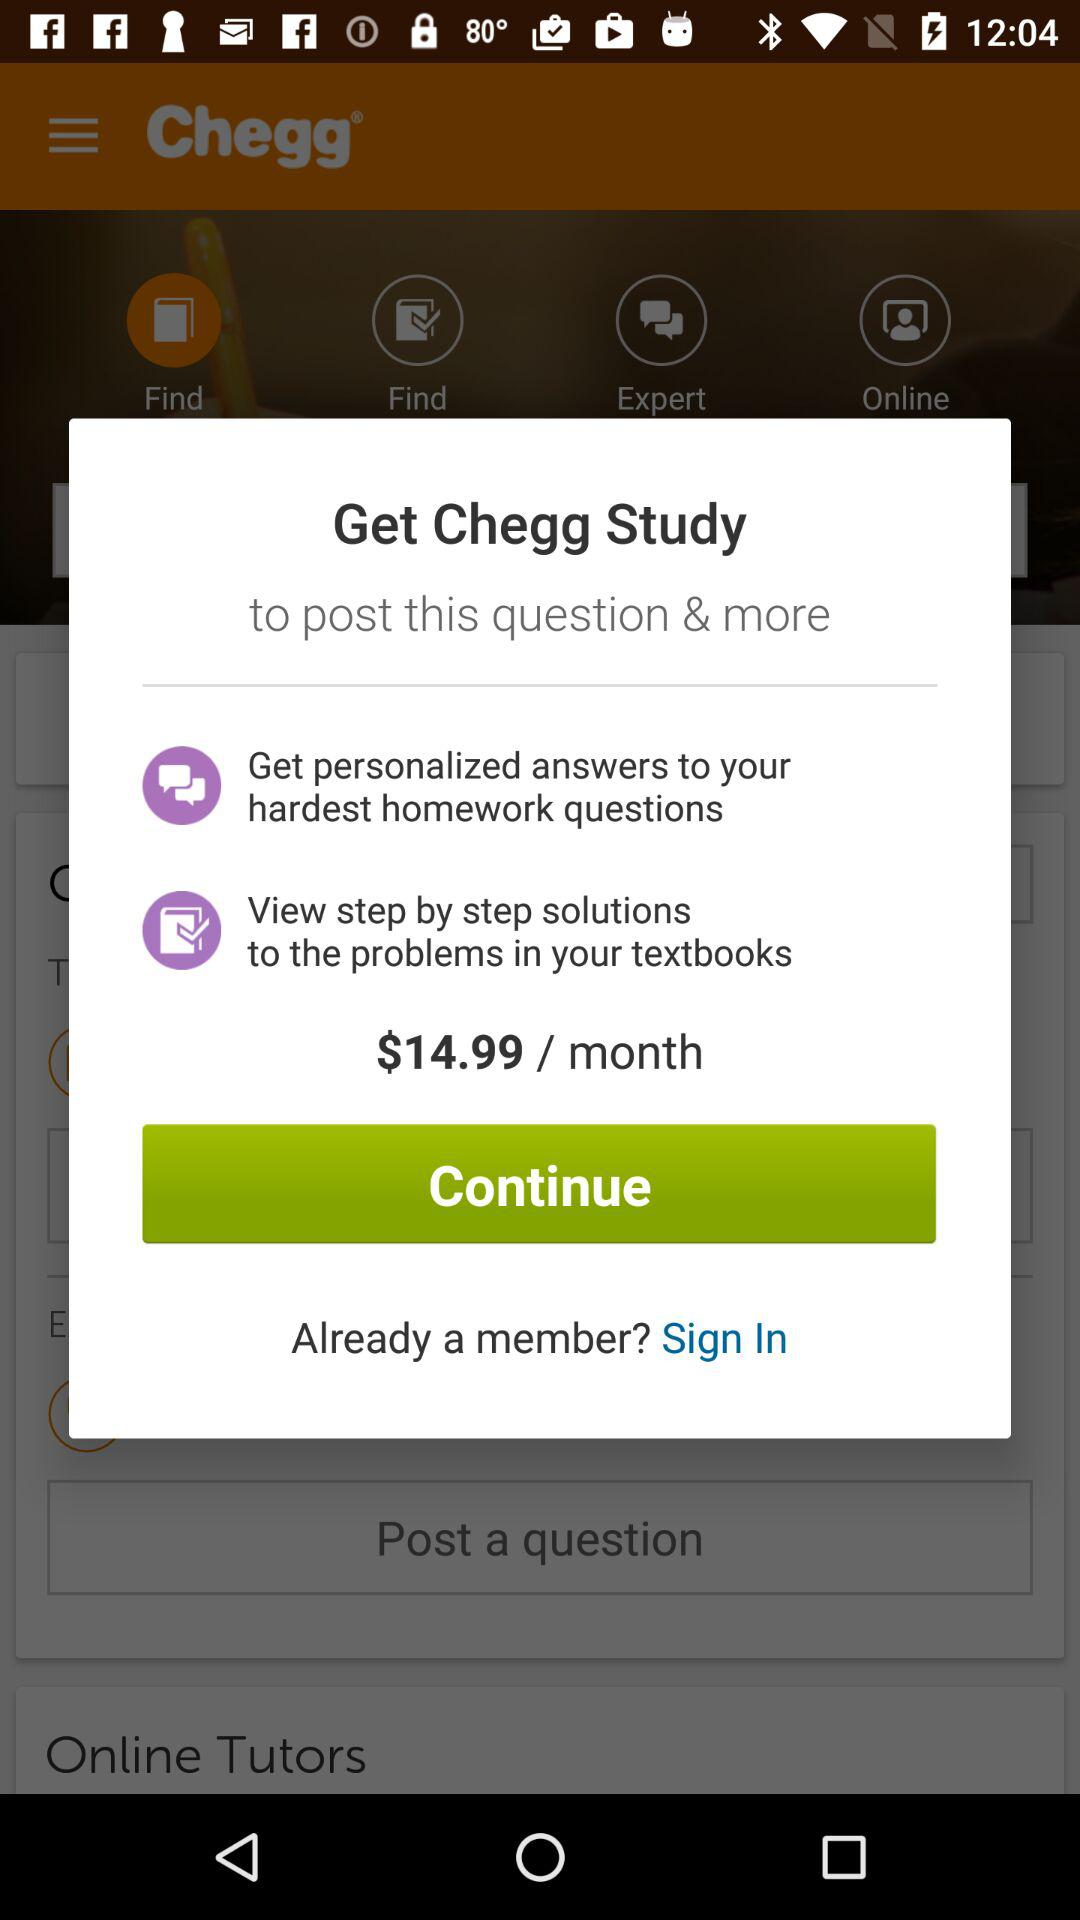Who are the online tutors?
When the provided information is insufficient, respond with <no answer>. <no answer> 